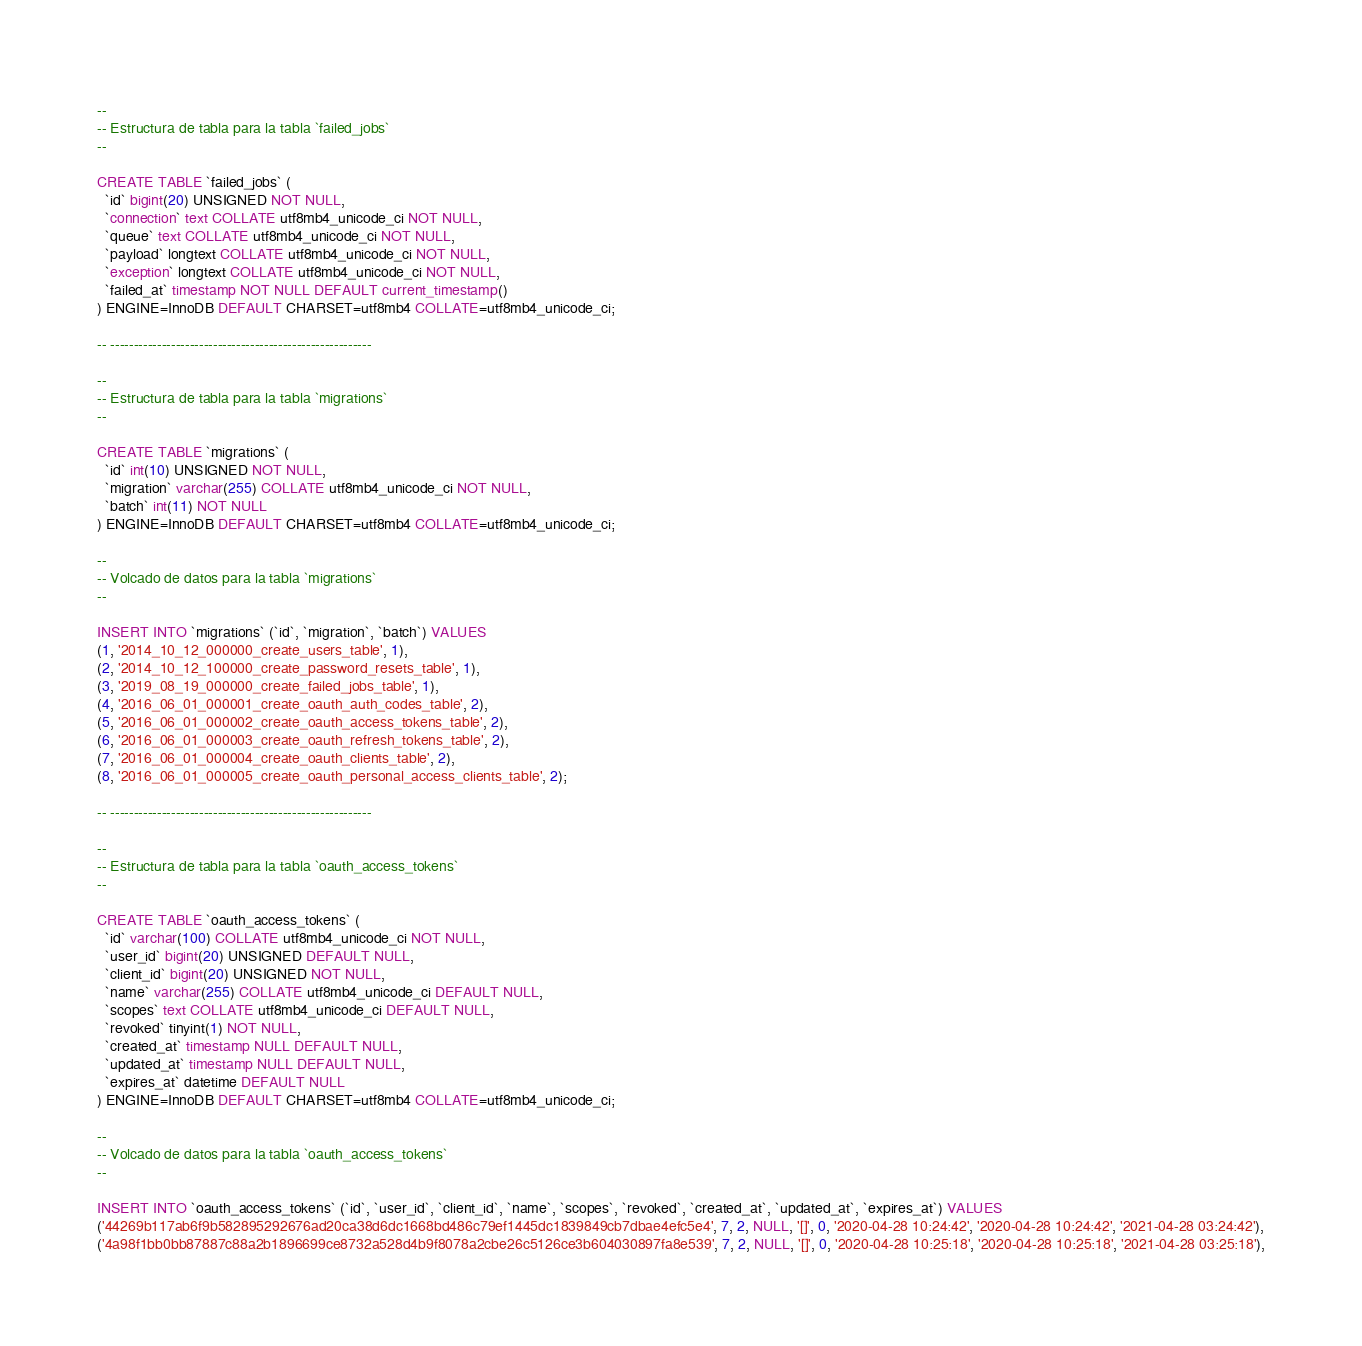<code> <loc_0><loc_0><loc_500><loc_500><_SQL_>
--
-- Estructura de tabla para la tabla `failed_jobs`
--

CREATE TABLE `failed_jobs` (
  `id` bigint(20) UNSIGNED NOT NULL,
  `connection` text COLLATE utf8mb4_unicode_ci NOT NULL,
  `queue` text COLLATE utf8mb4_unicode_ci NOT NULL,
  `payload` longtext COLLATE utf8mb4_unicode_ci NOT NULL,
  `exception` longtext COLLATE utf8mb4_unicode_ci NOT NULL,
  `failed_at` timestamp NOT NULL DEFAULT current_timestamp()
) ENGINE=InnoDB DEFAULT CHARSET=utf8mb4 COLLATE=utf8mb4_unicode_ci;

-- --------------------------------------------------------

--
-- Estructura de tabla para la tabla `migrations`
--

CREATE TABLE `migrations` (
  `id` int(10) UNSIGNED NOT NULL,
  `migration` varchar(255) COLLATE utf8mb4_unicode_ci NOT NULL,
  `batch` int(11) NOT NULL
) ENGINE=InnoDB DEFAULT CHARSET=utf8mb4 COLLATE=utf8mb4_unicode_ci;

--
-- Volcado de datos para la tabla `migrations`
--

INSERT INTO `migrations` (`id`, `migration`, `batch`) VALUES
(1, '2014_10_12_000000_create_users_table', 1),
(2, '2014_10_12_100000_create_password_resets_table', 1),
(3, '2019_08_19_000000_create_failed_jobs_table', 1),
(4, '2016_06_01_000001_create_oauth_auth_codes_table', 2),
(5, '2016_06_01_000002_create_oauth_access_tokens_table', 2),
(6, '2016_06_01_000003_create_oauth_refresh_tokens_table', 2),
(7, '2016_06_01_000004_create_oauth_clients_table', 2),
(8, '2016_06_01_000005_create_oauth_personal_access_clients_table', 2);

-- --------------------------------------------------------

--
-- Estructura de tabla para la tabla `oauth_access_tokens`
--

CREATE TABLE `oauth_access_tokens` (
  `id` varchar(100) COLLATE utf8mb4_unicode_ci NOT NULL,
  `user_id` bigint(20) UNSIGNED DEFAULT NULL,
  `client_id` bigint(20) UNSIGNED NOT NULL,
  `name` varchar(255) COLLATE utf8mb4_unicode_ci DEFAULT NULL,
  `scopes` text COLLATE utf8mb4_unicode_ci DEFAULT NULL,
  `revoked` tinyint(1) NOT NULL,
  `created_at` timestamp NULL DEFAULT NULL,
  `updated_at` timestamp NULL DEFAULT NULL,
  `expires_at` datetime DEFAULT NULL
) ENGINE=InnoDB DEFAULT CHARSET=utf8mb4 COLLATE=utf8mb4_unicode_ci;

--
-- Volcado de datos para la tabla `oauth_access_tokens`
--

INSERT INTO `oauth_access_tokens` (`id`, `user_id`, `client_id`, `name`, `scopes`, `revoked`, `created_at`, `updated_at`, `expires_at`) VALUES
('44269b117ab6f9b582895292676ad20ca38d6dc1668bd486c79ef1445dc1839849cb7dbae4efc5e4', 7, 2, NULL, '[]', 0, '2020-04-28 10:24:42', '2020-04-28 10:24:42', '2021-04-28 03:24:42'),
('4a98f1bb0bb87887c88a2b1896699ce8732a528d4b9f8078a2cbe26c5126ce3b604030897fa8e539', 7, 2, NULL, '[]', 0, '2020-04-28 10:25:18', '2020-04-28 10:25:18', '2021-04-28 03:25:18'),</code> 